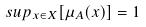Convert formula to latex. <formula><loc_0><loc_0><loc_500><loc_500>s u p _ { x \in X } [ \mu _ { A } ( x ) ] = 1</formula> 